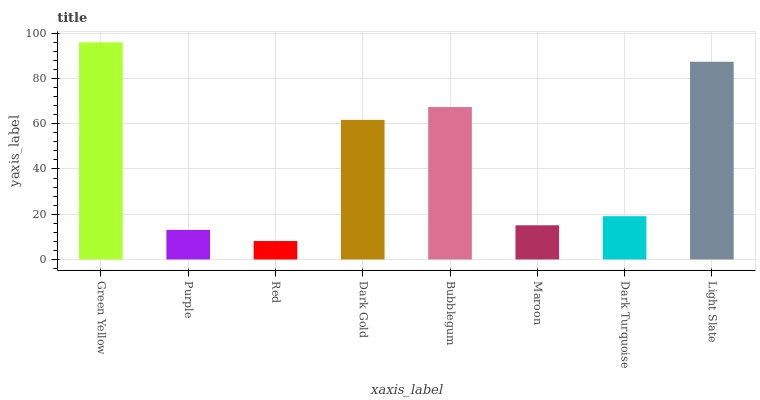Is Purple the minimum?
Answer yes or no. No. Is Purple the maximum?
Answer yes or no. No. Is Green Yellow greater than Purple?
Answer yes or no. Yes. Is Purple less than Green Yellow?
Answer yes or no. Yes. Is Purple greater than Green Yellow?
Answer yes or no. No. Is Green Yellow less than Purple?
Answer yes or no. No. Is Dark Gold the high median?
Answer yes or no. Yes. Is Dark Turquoise the low median?
Answer yes or no. Yes. Is Maroon the high median?
Answer yes or no. No. Is Purple the low median?
Answer yes or no. No. 